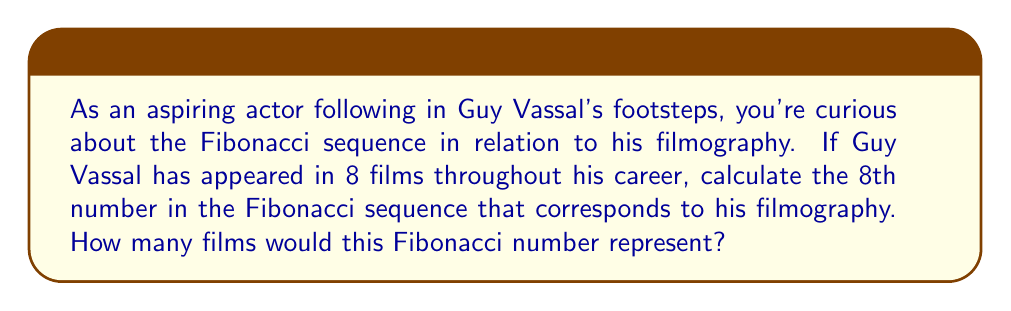Show me your answer to this math problem. Let's approach this step-by-step:

1) First, recall the Fibonacci sequence: Each number is the sum of the two preceding ones, starting from 0 and 1.

2) Let's write out the first 8 terms of the sequence:

   $F_1 = 1$
   $F_2 = 1$
   $F_3 = F_1 + F_2 = 1 + 1 = 2$
   $F_4 = F_2 + F_3 = 1 + 2 = 3$
   $F_5 = F_3 + F_4 = 2 + 3 = 5$
   $F_6 = F_4 + F_5 = 3 + 5 = 8$
   $F_7 = F_5 + F_6 = 5 + 8 = 13$
   $F_8 = F_6 + F_7 = 8 + 13 = 21$

3) We can express this mathematically as:

   $$F_n = F_{n-1} + F_{n-2}$$

   where $F_n$ is the nth Fibonacci number.

4) Therefore, the 8th Fibonacci number is 21.

5) In the context of the question, this would represent 21 films in the hypothetical Fibonacci-based filmography.
Answer: 21 films 